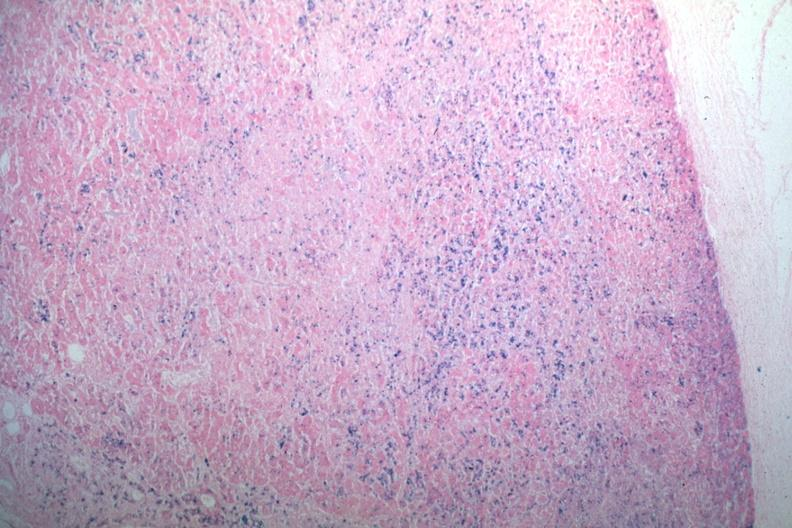does abdomen show iron stain abundant iron?
Answer the question using a single word or phrase. No 